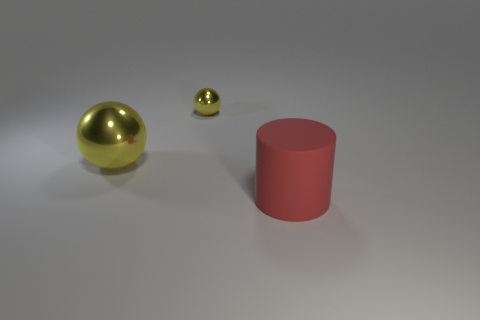How many metal objects are behind the big yellow ball and to the left of the tiny object? There are no metal objects positioned behind the big yellow ball and to the left of the tiny object. The space in that specified area is clear. 